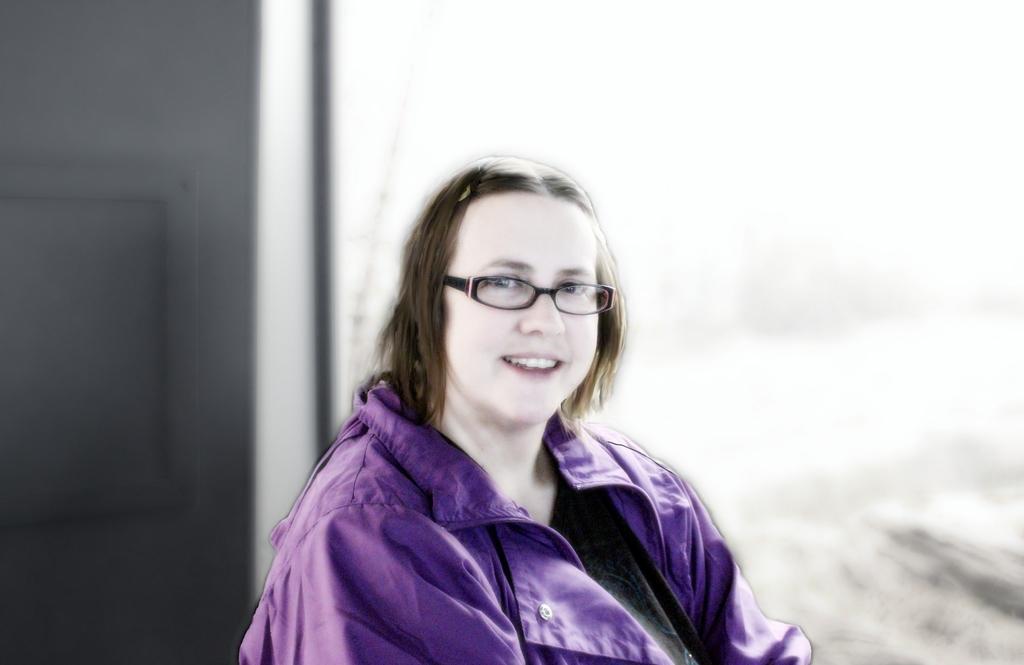How would you summarize this image in a sentence or two? In this image we can see a woman wearing purple color jacket and spectacles is here. The background of the image is blurred. 